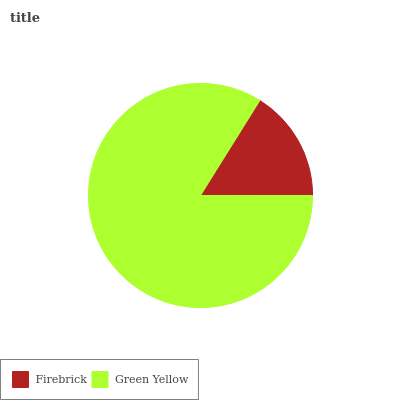Is Firebrick the minimum?
Answer yes or no. Yes. Is Green Yellow the maximum?
Answer yes or no. Yes. Is Green Yellow the minimum?
Answer yes or no. No. Is Green Yellow greater than Firebrick?
Answer yes or no. Yes. Is Firebrick less than Green Yellow?
Answer yes or no. Yes. Is Firebrick greater than Green Yellow?
Answer yes or no. No. Is Green Yellow less than Firebrick?
Answer yes or no. No. Is Green Yellow the high median?
Answer yes or no. Yes. Is Firebrick the low median?
Answer yes or no. Yes. Is Firebrick the high median?
Answer yes or no. No. Is Green Yellow the low median?
Answer yes or no. No. 